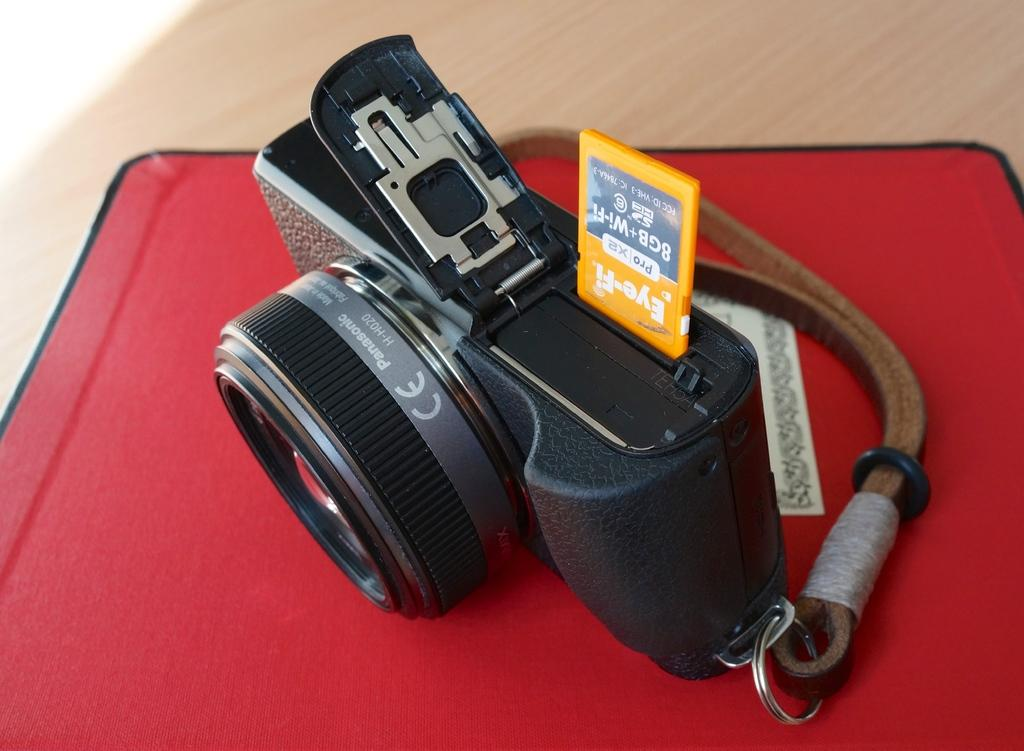What is the main object in the image? There is a camera in the image. What is the camera placed on? The camera is on a red object. Where is the red object located? The red object is on the floor. What type of playground equipment can be seen in the image? There is no playground equipment present in the image. How does the camera relate to the person's financial account in the image? There is no mention of a financial account or any connection to the camera in the image. 